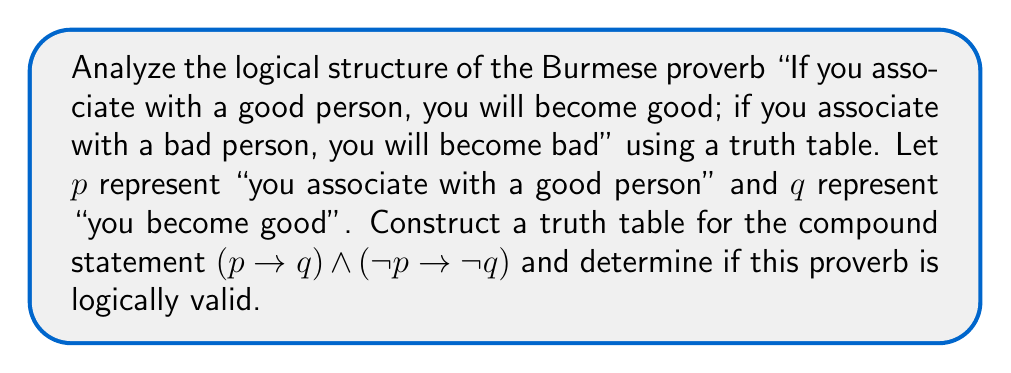Can you answer this question? Let's break this down step-by-step:

1) First, we need to translate the proverb into symbolic logic:
   - "If you associate with a good person, you will become good" translates to $p \rightarrow q$
   - "If you associate with a bad person, you will become bad" translates to $\neg p \rightarrow \neg q$
   - The proverb implies both statements are true, so we connect them with a conjunction: $(p \rightarrow q) \land (\neg p \rightarrow \neg q)$

2) Now, let's construct the truth table:

   $$\begin{array}{|c|c|c|c|c|c|c|}
   \hline
   p & q & \neg p & \neg q & p \rightarrow q & \neg p \rightarrow \neg q & (p \rightarrow q) \land (\neg p \rightarrow \neg q) \\
   \hline
   T & T & F & F & T & T & T \\
   T & F & F & T & F & T & F \\
   F & T & T & F & T & F & F \\
   F & F & T & T & T & T & T \\
   \hline
   \end{array}$$

3) Let's evaluate each column:
   - $\neg p$ and $\neg q$ are simple negations
   - $p \rightarrow q$ is false only when $p$ is true and $q$ is false
   - $\neg p \rightarrow \neg q$ is false only when $\neg p$ is true and $\neg q$ is false, which is when $p$ is false and $q$ is true
   - The final column is the conjunction of the two implications

4) For a statement to be logically valid, it must be true for all possible truth value assignments. In this case, we see that the final column is not always true.

5) Specifically, the proverb fails when:
   - $p$ is true and $q$ is false (you associate with a good person but don't become good)
   - $p$ is false and $q$ is true (you associate with a bad person but become good)

6) These scenarios reveal the logical flaw in the proverb: it assumes a deterministic relationship between association and personal character, which may not always hold in reality.
Answer: The Burmese proverb is not logically valid. The truth table shows that the compound statement $(p \rightarrow q) \land (\neg p \rightarrow \neg q)$ is not a tautology, as it is false in two scenarios: when $p$ is true and $q$ is false, and when $p$ is false and $q$ is true. 